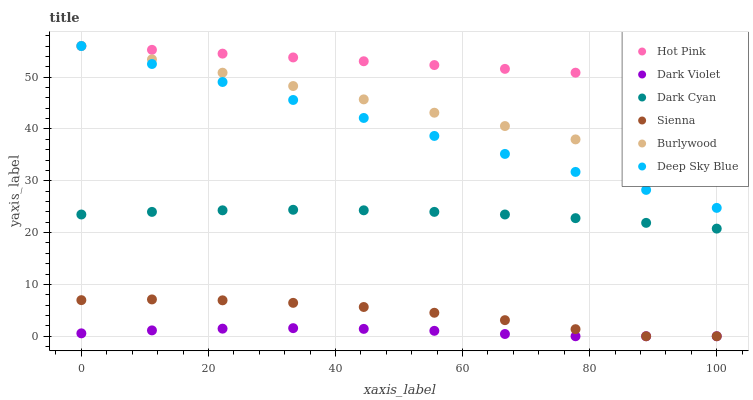Does Dark Violet have the minimum area under the curve?
Answer yes or no. Yes. Does Hot Pink have the maximum area under the curve?
Answer yes or no. Yes. Does Hot Pink have the minimum area under the curve?
Answer yes or no. No. Does Dark Violet have the maximum area under the curve?
Answer yes or no. No. Is Hot Pink the smoothest?
Answer yes or no. Yes. Is Sienna the roughest?
Answer yes or no. Yes. Is Dark Violet the smoothest?
Answer yes or no. No. Is Dark Violet the roughest?
Answer yes or no. No. Does Dark Violet have the lowest value?
Answer yes or no. Yes. Does Hot Pink have the lowest value?
Answer yes or no. No. Does Deep Sky Blue have the highest value?
Answer yes or no. Yes. Does Dark Violet have the highest value?
Answer yes or no. No. Is Dark Cyan less than Hot Pink?
Answer yes or no. Yes. Is Burlywood greater than Sienna?
Answer yes or no. Yes. Does Sienna intersect Dark Violet?
Answer yes or no. Yes. Is Sienna less than Dark Violet?
Answer yes or no. No. Is Sienna greater than Dark Violet?
Answer yes or no. No. Does Dark Cyan intersect Hot Pink?
Answer yes or no. No. 